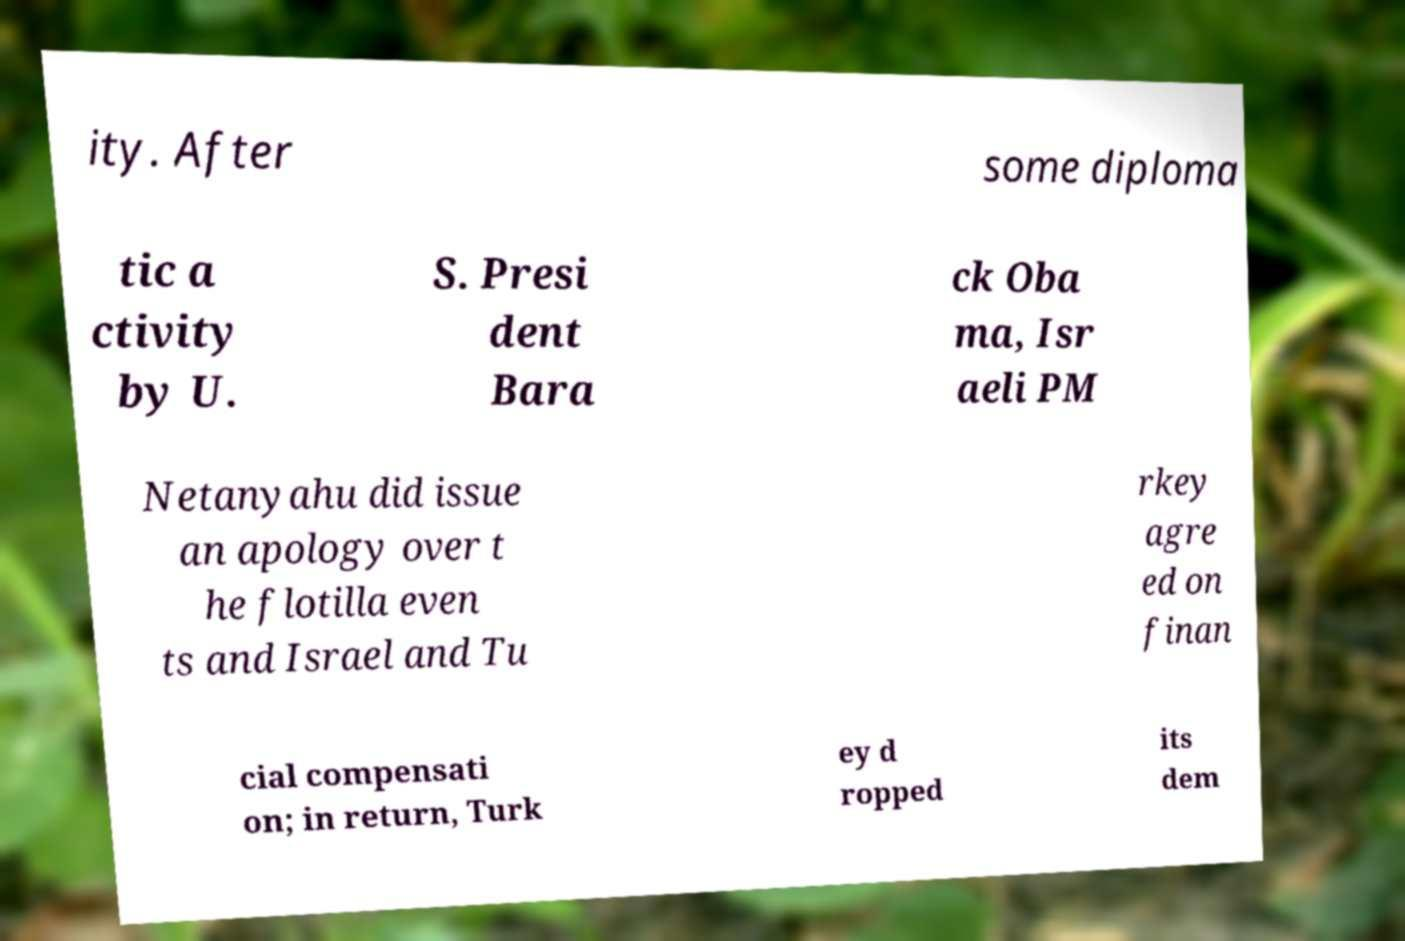Please identify and transcribe the text found in this image. ity. After some diploma tic a ctivity by U. S. Presi dent Bara ck Oba ma, Isr aeli PM Netanyahu did issue an apology over t he flotilla even ts and Israel and Tu rkey agre ed on finan cial compensati on; in return, Turk ey d ropped its dem 